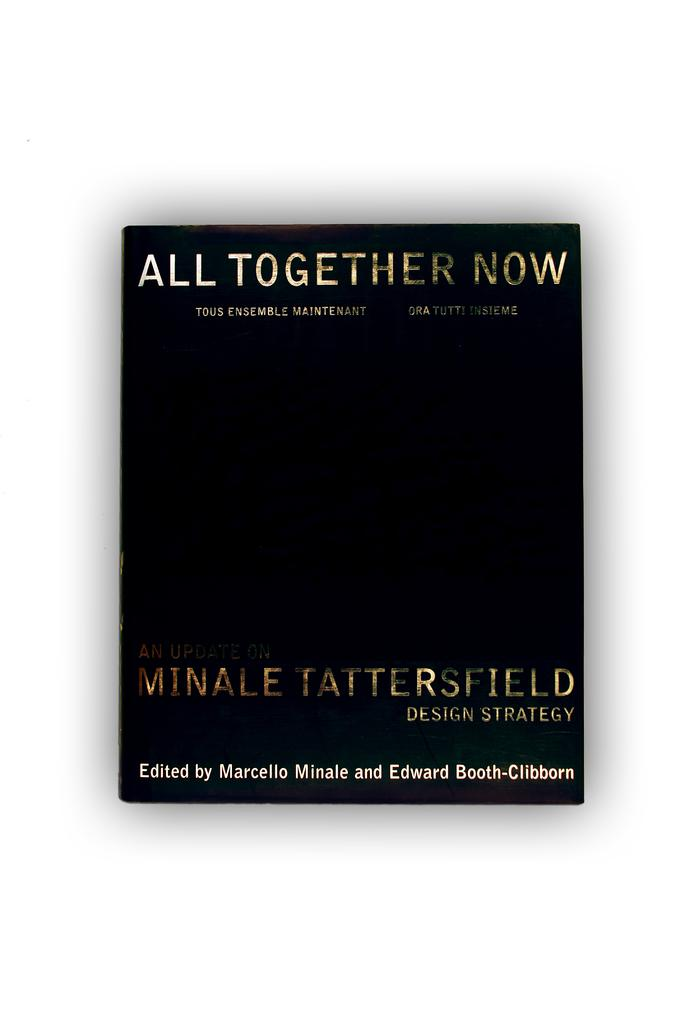<image>
Give a short and clear explanation of the subsequent image. All Together Now, a book by Marcello Minale sits against a white background 